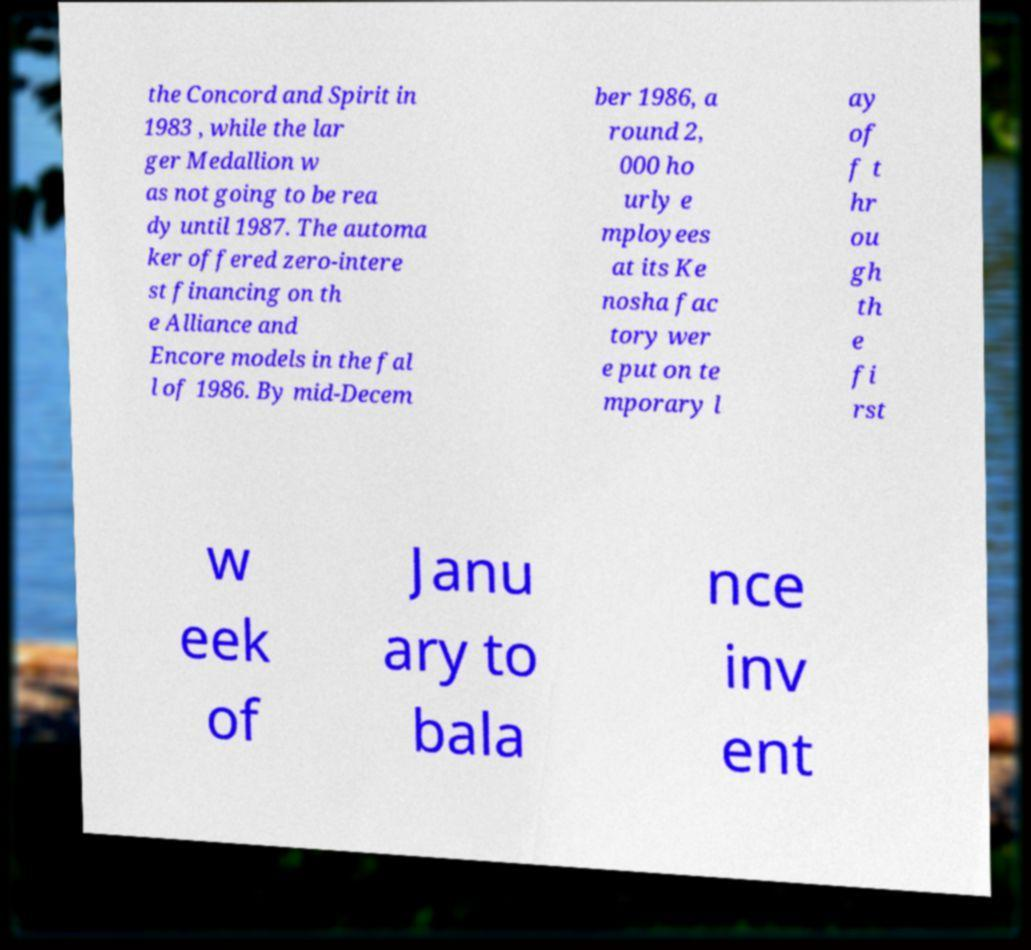Please read and relay the text visible in this image. What does it say? the Concord and Spirit in 1983 , while the lar ger Medallion w as not going to be rea dy until 1987. The automa ker offered zero-intere st financing on th e Alliance and Encore models in the fal l of 1986. By mid-Decem ber 1986, a round 2, 000 ho urly e mployees at its Ke nosha fac tory wer e put on te mporary l ay of f t hr ou gh th e fi rst w eek of Janu ary to bala nce inv ent 